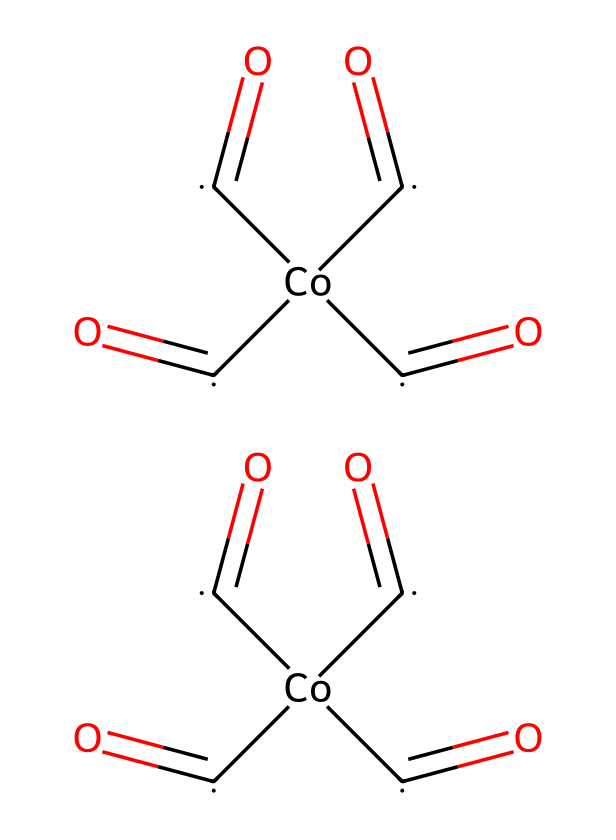How many carbonyl groups are present in cobalt octacarbonyl? The chemical structure indicates that there are eight carbonyl groups, each represented by a carbon atom double-bonded to an oxygen atom. The notation [C](=O) shows this relationship and counts up to eight in the entire structure.
Answer: eight What is the coordination number of cobalt in cobalt octacarbonyl? Cobalt is surrounded by eight carbonyl ligands within the structure, leading to a coordination number of eight. This can be counted through the attached carbonyl groups, which interact directly with cobalt.
Answer: eight What is the oxidation state of cobalt in cobalt octacarbonyl? Analyzing the structure, cobalt is bonded to eight CO groups, each neutral, indicating cobalt is in the zero oxidation state. This is determined because carbonyls are neutral ligands and do not contribute to a positive charge.
Answer: zero What type of bonding is present in the C=O groups of cobalt octacarbonyl? In the carbonyl (C=O) groups, there is double bonding—comprising one sigma bond and one pi bond. The presence of the double bond can be identified from the notation (C)(=O) in the SMILES format.
Answer: double bond What is the role of cobalt octacarbonyl in the synthesis of lightweight chassis materials? Cobalt octacarbonyl acts as a precursor in the synthesis of specialized polymers, contributing to enhanced properties such as strength and lightweight characteristics. This is based on its organometallic nature providing unique polymer-building characteristics.
Answer: precursor 